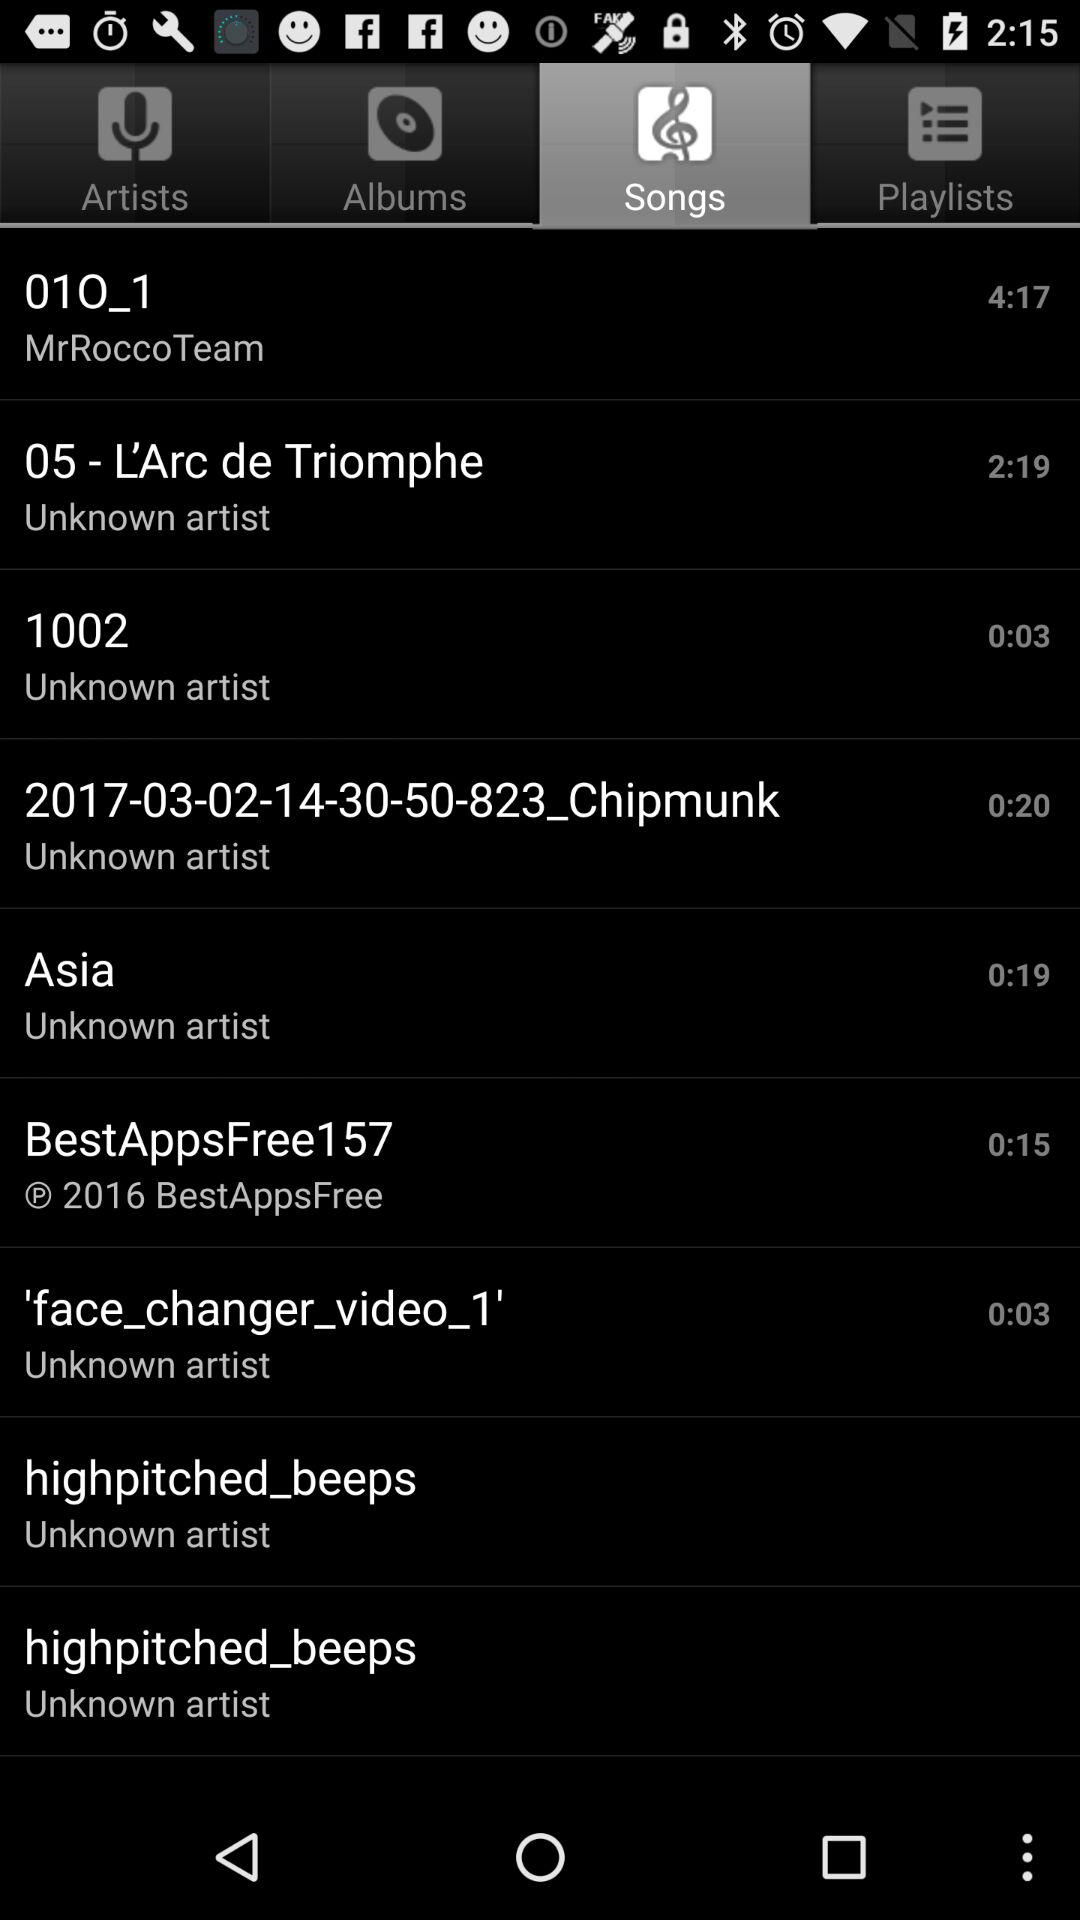What is the time duration of the song 010_1? The time duration of the song is 4:17. 